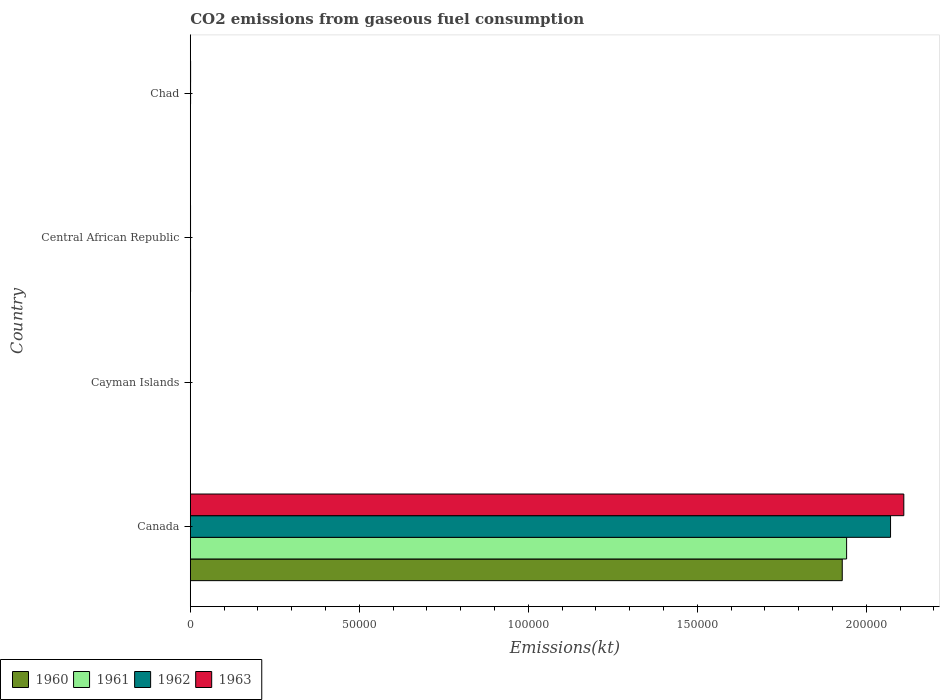How many different coloured bars are there?
Provide a short and direct response. 4. How many groups of bars are there?
Provide a short and direct response. 4. Are the number of bars per tick equal to the number of legend labels?
Provide a succinct answer. Yes. How many bars are there on the 3rd tick from the bottom?
Give a very brief answer. 4. What is the label of the 2nd group of bars from the top?
Provide a succinct answer. Central African Republic. What is the amount of CO2 emitted in 1963 in Central African Republic?
Your response must be concise. 73.34. Across all countries, what is the maximum amount of CO2 emitted in 1962?
Offer a terse response. 2.07e+05. Across all countries, what is the minimum amount of CO2 emitted in 1963?
Offer a terse response. 11. In which country was the amount of CO2 emitted in 1961 minimum?
Provide a short and direct response. Cayman Islands. What is the total amount of CO2 emitted in 1960 in the graph?
Ensure brevity in your answer.  1.93e+05. What is the difference between the amount of CO2 emitted in 1963 in Canada and that in Central African Republic?
Your response must be concise. 2.11e+05. What is the difference between the amount of CO2 emitted in 1961 in Cayman Islands and the amount of CO2 emitted in 1960 in Central African Republic?
Ensure brevity in your answer.  -77.01. What is the average amount of CO2 emitted in 1962 per country?
Provide a succinct answer. 5.18e+04. What is the difference between the amount of CO2 emitted in 1961 and amount of CO2 emitted in 1963 in Canada?
Keep it short and to the point. -1.69e+04. What is the ratio of the amount of CO2 emitted in 1963 in Central African Republic to that in Chad?
Your answer should be compact. 0.8. Is the amount of CO2 emitted in 1963 in Canada less than that in Central African Republic?
Provide a succinct answer. No. Is the difference between the amount of CO2 emitted in 1961 in Cayman Islands and Central African Republic greater than the difference between the amount of CO2 emitted in 1963 in Cayman Islands and Central African Republic?
Offer a terse response. No. What is the difference between the highest and the second highest amount of CO2 emitted in 1960?
Offer a terse response. 1.93e+05. What is the difference between the highest and the lowest amount of CO2 emitted in 1963?
Ensure brevity in your answer.  2.11e+05. In how many countries, is the amount of CO2 emitted in 1963 greater than the average amount of CO2 emitted in 1963 taken over all countries?
Provide a succinct answer. 1. Is it the case that in every country, the sum of the amount of CO2 emitted in 1963 and amount of CO2 emitted in 1960 is greater than the sum of amount of CO2 emitted in 1962 and amount of CO2 emitted in 1961?
Offer a terse response. No. What does the 1st bar from the bottom in Chad represents?
Keep it short and to the point. 1960. How many bars are there?
Provide a short and direct response. 16. How many countries are there in the graph?
Offer a very short reply. 4. Are the values on the major ticks of X-axis written in scientific E-notation?
Make the answer very short. No. Does the graph contain grids?
Your answer should be compact. No. How many legend labels are there?
Your answer should be very brief. 4. How are the legend labels stacked?
Ensure brevity in your answer.  Horizontal. What is the title of the graph?
Your response must be concise. CO2 emissions from gaseous fuel consumption. Does "1999" appear as one of the legend labels in the graph?
Keep it short and to the point. No. What is the label or title of the X-axis?
Offer a terse response. Emissions(kt). What is the label or title of the Y-axis?
Ensure brevity in your answer.  Country. What is the Emissions(kt) of 1960 in Canada?
Offer a terse response. 1.93e+05. What is the Emissions(kt) in 1961 in Canada?
Make the answer very short. 1.94e+05. What is the Emissions(kt) in 1962 in Canada?
Give a very brief answer. 2.07e+05. What is the Emissions(kt) in 1963 in Canada?
Keep it short and to the point. 2.11e+05. What is the Emissions(kt) in 1960 in Cayman Islands?
Ensure brevity in your answer.  11. What is the Emissions(kt) in 1961 in Cayman Islands?
Your answer should be very brief. 11. What is the Emissions(kt) in 1962 in Cayman Islands?
Provide a succinct answer. 11. What is the Emissions(kt) of 1963 in Cayman Islands?
Make the answer very short. 11. What is the Emissions(kt) of 1960 in Central African Republic?
Make the answer very short. 88.01. What is the Emissions(kt) of 1961 in Central African Republic?
Keep it short and to the point. 88.01. What is the Emissions(kt) of 1962 in Central African Republic?
Make the answer very short. 73.34. What is the Emissions(kt) of 1963 in Central African Republic?
Keep it short and to the point. 73.34. What is the Emissions(kt) in 1960 in Chad?
Offer a very short reply. 55.01. What is the Emissions(kt) of 1961 in Chad?
Your answer should be compact. 51.34. What is the Emissions(kt) of 1962 in Chad?
Provide a short and direct response. 84.34. What is the Emissions(kt) of 1963 in Chad?
Ensure brevity in your answer.  91.67. Across all countries, what is the maximum Emissions(kt) of 1960?
Give a very brief answer. 1.93e+05. Across all countries, what is the maximum Emissions(kt) in 1961?
Offer a very short reply. 1.94e+05. Across all countries, what is the maximum Emissions(kt) of 1962?
Your response must be concise. 2.07e+05. Across all countries, what is the maximum Emissions(kt) in 1963?
Your response must be concise. 2.11e+05. Across all countries, what is the minimum Emissions(kt) of 1960?
Provide a short and direct response. 11. Across all countries, what is the minimum Emissions(kt) in 1961?
Your answer should be compact. 11. Across all countries, what is the minimum Emissions(kt) in 1962?
Make the answer very short. 11. Across all countries, what is the minimum Emissions(kt) of 1963?
Ensure brevity in your answer.  11. What is the total Emissions(kt) of 1960 in the graph?
Your response must be concise. 1.93e+05. What is the total Emissions(kt) in 1961 in the graph?
Keep it short and to the point. 1.94e+05. What is the total Emissions(kt) in 1962 in the graph?
Your answer should be compact. 2.07e+05. What is the total Emissions(kt) of 1963 in the graph?
Your response must be concise. 2.11e+05. What is the difference between the Emissions(kt) in 1960 in Canada and that in Cayman Islands?
Offer a terse response. 1.93e+05. What is the difference between the Emissions(kt) of 1961 in Canada and that in Cayman Islands?
Your answer should be very brief. 1.94e+05. What is the difference between the Emissions(kt) of 1962 in Canada and that in Cayman Islands?
Your answer should be very brief. 2.07e+05. What is the difference between the Emissions(kt) of 1963 in Canada and that in Cayman Islands?
Provide a short and direct response. 2.11e+05. What is the difference between the Emissions(kt) in 1960 in Canada and that in Central African Republic?
Your response must be concise. 1.93e+05. What is the difference between the Emissions(kt) of 1961 in Canada and that in Central African Republic?
Ensure brevity in your answer.  1.94e+05. What is the difference between the Emissions(kt) of 1962 in Canada and that in Central African Republic?
Your answer should be very brief. 2.07e+05. What is the difference between the Emissions(kt) of 1963 in Canada and that in Central African Republic?
Your response must be concise. 2.11e+05. What is the difference between the Emissions(kt) of 1960 in Canada and that in Chad?
Make the answer very short. 1.93e+05. What is the difference between the Emissions(kt) of 1961 in Canada and that in Chad?
Offer a terse response. 1.94e+05. What is the difference between the Emissions(kt) of 1962 in Canada and that in Chad?
Provide a short and direct response. 2.07e+05. What is the difference between the Emissions(kt) of 1963 in Canada and that in Chad?
Ensure brevity in your answer.  2.11e+05. What is the difference between the Emissions(kt) of 1960 in Cayman Islands and that in Central African Republic?
Offer a terse response. -77.01. What is the difference between the Emissions(kt) of 1961 in Cayman Islands and that in Central African Republic?
Ensure brevity in your answer.  -77.01. What is the difference between the Emissions(kt) in 1962 in Cayman Islands and that in Central African Republic?
Your answer should be compact. -62.34. What is the difference between the Emissions(kt) in 1963 in Cayman Islands and that in Central African Republic?
Offer a terse response. -62.34. What is the difference between the Emissions(kt) of 1960 in Cayman Islands and that in Chad?
Keep it short and to the point. -44. What is the difference between the Emissions(kt) in 1961 in Cayman Islands and that in Chad?
Provide a short and direct response. -40.34. What is the difference between the Emissions(kt) of 1962 in Cayman Islands and that in Chad?
Offer a terse response. -73.34. What is the difference between the Emissions(kt) of 1963 in Cayman Islands and that in Chad?
Offer a very short reply. -80.67. What is the difference between the Emissions(kt) in 1960 in Central African Republic and that in Chad?
Offer a terse response. 33. What is the difference between the Emissions(kt) in 1961 in Central African Republic and that in Chad?
Your response must be concise. 36.67. What is the difference between the Emissions(kt) of 1962 in Central African Republic and that in Chad?
Offer a very short reply. -11. What is the difference between the Emissions(kt) of 1963 in Central African Republic and that in Chad?
Keep it short and to the point. -18.34. What is the difference between the Emissions(kt) in 1960 in Canada and the Emissions(kt) in 1961 in Cayman Islands?
Give a very brief answer. 1.93e+05. What is the difference between the Emissions(kt) of 1960 in Canada and the Emissions(kt) of 1962 in Cayman Islands?
Offer a terse response. 1.93e+05. What is the difference between the Emissions(kt) of 1960 in Canada and the Emissions(kt) of 1963 in Cayman Islands?
Keep it short and to the point. 1.93e+05. What is the difference between the Emissions(kt) in 1961 in Canada and the Emissions(kt) in 1962 in Cayman Islands?
Ensure brevity in your answer.  1.94e+05. What is the difference between the Emissions(kt) of 1961 in Canada and the Emissions(kt) of 1963 in Cayman Islands?
Keep it short and to the point. 1.94e+05. What is the difference between the Emissions(kt) of 1962 in Canada and the Emissions(kt) of 1963 in Cayman Islands?
Provide a short and direct response. 2.07e+05. What is the difference between the Emissions(kt) of 1960 in Canada and the Emissions(kt) of 1961 in Central African Republic?
Ensure brevity in your answer.  1.93e+05. What is the difference between the Emissions(kt) in 1960 in Canada and the Emissions(kt) in 1962 in Central African Republic?
Keep it short and to the point. 1.93e+05. What is the difference between the Emissions(kt) of 1960 in Canada and the Emissions(kt) of 1963 in Central African Republic?
Offer a very short reply. 1.93e+05. What is the difference between the Emissions(kt) in 1961 in Canada and the Emissions(kt) in 1962 in Central African Republic?
Your answer should be compact. 1.94e+05. What is the difference between the Emissions(kt) in 1961 in Canada and the Emissions(kt) in 1963 in Central African Republic?
Provide a short and direct response. 1.94e+05. What is the difference between the Emissions(kt) of 1962 in Canada and the Emissions(kt) of 1963 in Central African Republic?
Offer a very short reply. 2.07e+05. What is the difference between the Emissions(kt) in 1960 in Canada and the Emissions(kt) in 1961 in Chad?
Offer a terse response. 1.93e+05. What is the difference between the Emissions(kt) of 1960 in Canada and the Emissions(kt) of 1962 in Chad?
Provide a short and direct response. 1.93e+05. What is the difference between the Emissions(kt) of 1960 in Canada and the Emissions(kt) of 1963 in Chad?
Your answer should be compact. 1.93e+05. What is the difference between the Emissions(kt) in 1961 in Canada and the Emissions(kt) in 1962 in Chad?
Keep it short and to the point. 1.94e+05. What is the difference between the Emissions(kt) in 1961 in Canada and the Emissions(kt) in 1963 in Chad?
Offer a terse response. 1.94e+05. What is the difference between the Emissions(kt) of 1962 in Canada and the Emissions(kt) of 1963 in Chad?
Provide a succinct answer. 2.07e+05. What is the difference between the Emissions(kt) in 1960 in Cayman Islands and the Emissions(kt) in 1961 in Central African Republic?
Provide a succinct answer. -77.01. What is the difference between the Emissions(kt) of 1960 in Cayman Islands and the Emissions(kt) of 1962 in Central African Republic?
Keep it short and to the point. -62.34. What is the difference between the Emissions(kt) in 1960 in Cayman Islands and the Emissions(kt) in 1963 in Central African Republic?
Provide a succinct answer. -62.34. What is the difference between the Emissions(kt) of 1961 in Cayman Islands and the Emissions(kt) of 1962 in Central African Republic?
Provide a short and direct response. -62.34. What is the difference between the Emissions(kt) in 1961 in Cayman Islands and the Emissions(kt) in 1963 in Central African Republic?
Ensure brevity in your answer.  -62.34. What is the difference between the Emissions(kt) in 1962 in Cayman Islands and the Emissions(kt) in 1963 in Central African Republic?
Your response must be concise. -62.34. What is the difference between the Emissions(kt) of 1960 in Cayman Islands and the Emissions(kt) of 1961 in Chad?
Offer a terse response. -40.34. What is the difference between the Emissions(kt) of 1960 in Cayman Islands and the Emissions(kt) of 1962 in Chad?
Ensure brevity in your answer.  -73.34. What is the difference between the Emissions(kt) of 1960 in Cayman Islands and the Emissions(kt) of 1963 in Chad?
Give a very brief answer. -80.67. What is the difference between the Emissions(kt) of 1961 in Cayman Islands and the Emissions(kt) of 1962 in Chad?
Provide a succinct answer. -73.34. What is the difference between the Emissions(kt) of 1961 in Cayman Islands and the Emissions(kt) of 1963 in Chad?
Offer a very short reply. -80.67. What is the difference between the Emissions(kt) in 1962 in Cayman Islands and the Emissions(kt) in 1963 in Chad?
Your response must be concise. -80.67. What is the difference between the Emissions(kt) of 1960 in Central African Republic and the Emissions(kt) of 1961 in Chad?
Your response must be concise. 36.67. What is the difference between the Emissions(kt) of 1960 in Central African Republic and the Emissions(kt) of 1962 in Chad?
Your answer should be compact. 3.67. What is the difference between the Emissions(kt) in 1960 in Central African Republic and the Emissions(kt) in 1963 in Chad?
Offer a very short reply. -3.67. What is the difference between the Emissions(kt) in 1961 in Central African Republic and the Emissions(kt) in 1962 in Chad?
Give a very brief answer. 3.67. What is the difference between the Emissions(kt) in 1961 in Central African Republic and the Emissions(kt) in 1963 in Chad?
Your answer should be very brief. -3.67. What is the difference between the Emissions(kt) of 1962 in Central African Republic and the Emissions(kt) of 1963 in Chad?
Give a very brief answer. -18.34. What is the average Emissions(kt) of 1960 per country?
Give a very brief answer. 4.83e+04. What is the average Emissions(kt) in 1961 per country?
Your answer should be very brief. 4.86e+04. What is the average Emissions(kt) in 1962 per country?
Give a very brief answer. 5.18e+04. What is the average Emissions(kt) in 1963 per country?
Your answer should be very brief. 5.28e+04. What is the difference between the Emissions(kt) in 1960 and Emissions(kt) in 1961 in Canada?
Keep it short and to the point. -1287.12. What is the difference between the Emissions(kt) of 1960 and Emissions(kt) of 1962 in Canada?
Offer a terse response. -1.43e+04. What is the difference between the Emissions(kt) in 1960 and Emissions(kt) in 1963 in Canada?
Ensure brevity in your answer.  -1.82e+04. What is the difference between the Emissions(kt) of 1961 and Emissions(kt) of 1962 in Canada?
Keep it short and to the point. -1.30e+04. What is the difference between the Emissions(kt) in 1961 and Emissions(kt) in 1963 in Canada?
Offer a terse response. -1.69e+04. What is the difference between the Emissions(kt) in 1962 and Emissions(kt) in 1963 in Canada?
Ensure brevity in your answer.  -3923.69. What is the difference between the Emissions(kt) of 1960 and Emissions(kt) of 1962 in Cayman Islands?
Provide a succinct answer. 0. What is the difference between the Emissions(kt) of 1961 and Emissions(kt) of 1963 in Cayman Islands?
Your answer should be compact. 0. What is the difference between the Emissions(kt) in 1962 and Emissions(kt) in 1963 in Cayman Islands?
Your response must be concise. 0. What is the difference between the Emissions(kt) of 1960 and Emissions(kt) of 1962 in Central African Republic?
Keep it short and to the point. 14.67. What is the difference between the Emissions(kt) in 1960 and Emissions(kt) in 1963 in Central African Republic?
Provide a succinct answer. 14.67. What is the difference between the Emissions(kt) of 1961 and Emissions(kt) of 1962 in Central African Republic?
Your response must be concise. 14.67. What is the difference between the Emissions(kt) of 1961 and Emissions(kt) of 1963 in Central African Republic?
Your answer should be very brief. 14.67. What is the difference between the Emissions(kt) in 1960 and Emissions(kt) in 1961 in Chad?
Ensure brevity in your answer.  3.67. What is the difference between the Emissions(kt) in 1960 and Emissions(kt) in 1962 in Chad?
Offer a terse response. -29.34. What is the difference between the Emissions(kt) in 1960 and Emissions(kt) in 1963 in Chad?
Give a very brief answer. -36.67. What is the difference between the Emissions(kt) of 1961 and Emissions(kt) of 1962 in Chad?
Offer a terse response. -33. What is the difference between the Emissions(kt) of 1961 and Emissions(kt) of 1963 in Chad?
Offer a very short reply. -40.34. What is the difference between the Emissions(kt) of 1962 and Emissions(kt) of 1963 in Chad?
Provide a succinct answer. -7.33. What is the ratio of the Emissions(kt) of 1960 in Canada to that in Cayman Islands?
Keep it short and to the point. 1.75e+04. What is the ratio of the Emissions(kt) of 1961 in Canada to that in Cayman Islands?
Your answer should be compact. 1.77e+04. What is the ratio of the Emissions(kt) in 1962 in Canada to that in Cayman Islands?
Offer a terse response. 1.88e+04. What is the ratio of the Emissions(kt) in 1963 in Canada to that in Cayman Islands?
Your answer should be compact. 1.92e+04. What is the ratio of the Emissions(kt) of 1960 in Canada to that in Central African Republic?
Your answer should be compact. 2191.79. What is the ratio of the Emissions(kt) of 1961 in Canada to that in Central African Republic?
Your response must be concise. 2206.42. What is the ratio of the Emissions(kt) of 1962 in Canada to that in Central African Republic?
Give a very brief answer. 2825. What is the ratio of the Emissions(kt) of 1963 in Canada to that in Central African Republic?
Make the answer very short. 2878.5. What is the ratio of the Emissions(kt) in 1960 in Canada to that in Chad?
Provide a short and direct response. 3506.87. What is the ratio of the Emissions(kt) in 1961 in Canada to that in Chad?
Make the answer very short. 3782.43. What is the ratio of the Emissions(kt) of 1962 in Canada to that in Chad?
Make the answer very short. 2456.52. What is the ratio of the Emissions(kt) in 1963 in Canada to that in Chad?
Keep it short and to the point. 2302.8. What is the ratio of the Emissions(kt) of 1960 in Cayman Islands to that in Central African Republic?
Make the answer very short. 0.12. What is the ratio of the Emissions(kt) of 1961 in Cayman Islands to that in Central African Republic?
Offer a terse response. 0.12. What is the ratio of the Emissions(kt) in 1961 in Cayman Islands to that in Chad?
Your answer should be very brief. 0.21. What is the ratio of the Emissions(kt) in 1962 in Cayman Islands to that in Chad?
Provide a short and direct response. 0.13. What is the ratio of the Emissions(kt) of 1963 in Cayman Islands to that in Chad?
Your answer should be very brief. 0.12. What is the ratio of the Emissions(kt) of 1961 in Central African Republic to that in Chad?
Offer a very short reply. 1.71. What is the ratio of the Emissions(kt) of 1962 in Central African Republic to that in Chad?
Keep it short and to the point. 0.87. What is the ratio of the Emissions(kt) of 1963 in Central African Republic to that in Chad?
Offer a very short reply. 0.8. What is the difference between the highest and the second highest Emissions(kt) of 1960?
Keep it short and to the point. 1.93e+05. What is the difference between the highest and the second highest Emissions(kt) in 1961?
Provide a succinct answer. 1.94e+05. What is the difference between the highest and the second highest Emissions(kt) of 1962?
Offer a very short reply. 2.07e+05. What is the difference between the highest and the second highest Emissions(kt) in 1963?
Provide a short and direct response. 2.11e+05. What is the difference between the highest and the lowest Emissions(kt) of 1960?
Offer a very short reply. 1.93e+05. What is the difference between the highest and the lowest Emissions(kt) of 1961?
Your response must be concise. 1.94e+05. What is the difference between the highest and the lowest Emissions(kt) of 1962?
Your response must be concise. 2.07e+05. What is the difference between the highest and the lowest Emissions(kt) in 1963?
Offer a terse response. 2.11e+05. 